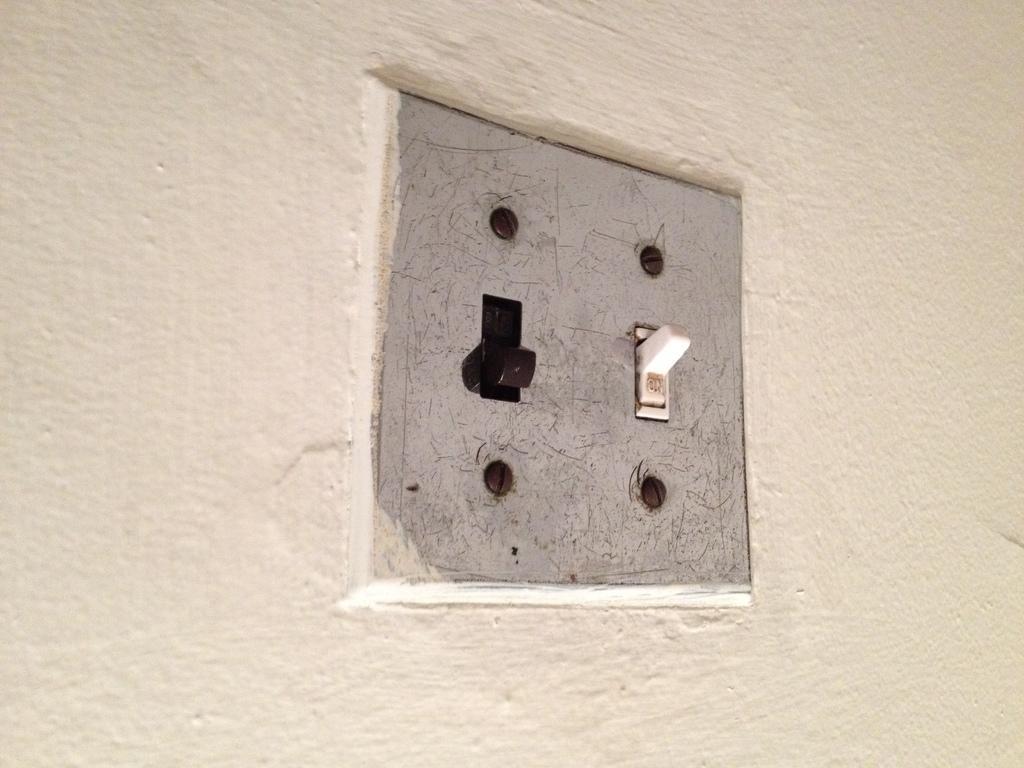Describe this image in one or two sentences. In this image there is a socket in the wall which is black and white in colour. 